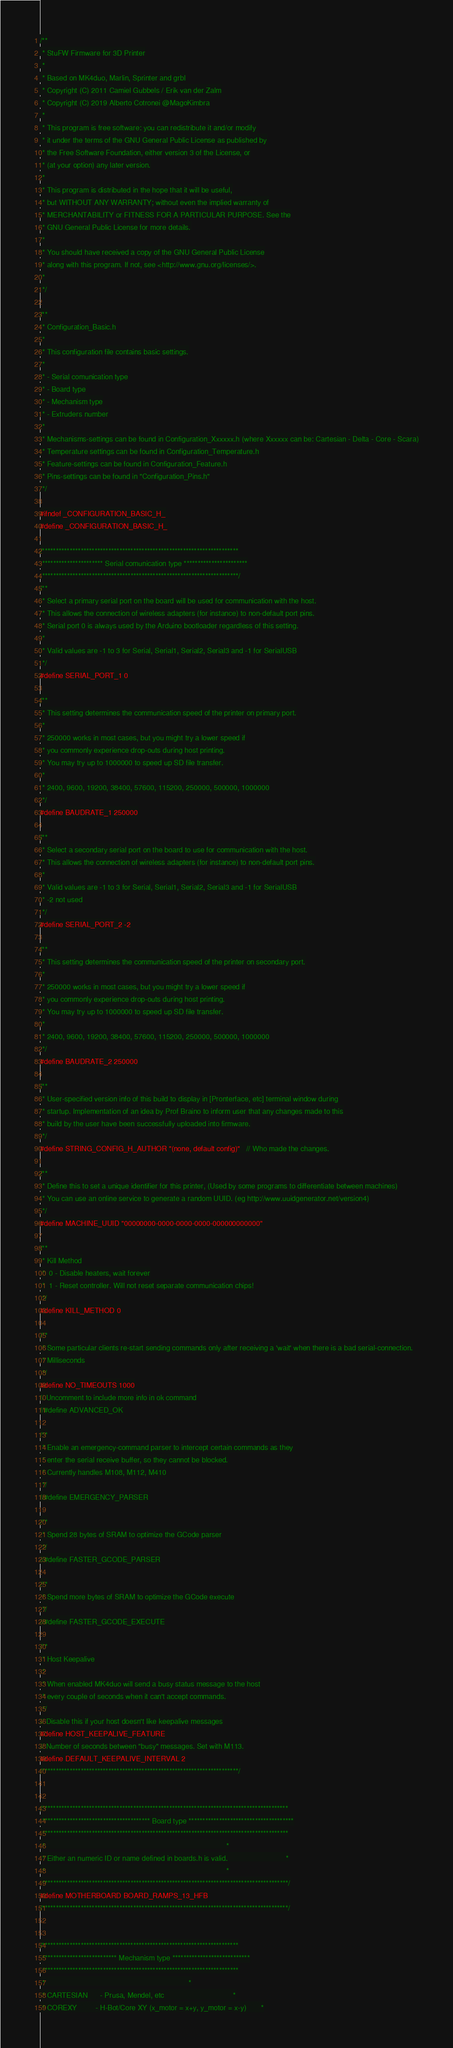<code> <loc_0><loc_0><loc_500><loc_500><_C_>/**
 * StuFW Firmware for 3D Printer
 *
 * Based on MK4duo, Marlin, Sprinter and grbl
 * Copyright (C) 2011 Camiel Gubbels / Erik van der Zalm
 * Copyright (C) 2019 Alberto Cotronei @MagoKimbra
 *
 * This program is free software: you can redistribute it and/or modify
 * it under the terms of the GNU General Public License as published by
 * the Free Software Foundation, either version 3 of the License, or
 * (at your option) any later version.
 *
 * This program is distributed in the hope that it will be useful,
 * but WITHOUT ANY WARRANTY; without even the implied warranty of
 * MERCHANTABILITY or FITNESS FOR A PARTICULAR PURPOSE. See the
 * GNU General Public License for more details.
 *
 * You should have received a copy of the GNU General Public License
 * along with this program. If not, see <http://www.gnu.org/licenses/>.
 *
 */

/**
 * Configuration_Basic.h
 *
 * This configuration file contains basic settings.
 *
 * - Serial comunication type
 * - Board type
 * - Mechanism type
 * - Extruders number
 *
 * Mechanisms-settings can be found in Configuration_Xxxxxx.h (where Xxxxxx can be: Cartesian - Delta - Core - Scara)
 * Temperature settings can be found in Configuration_Temperature.h
 * Feature-settings can be found in Configuration_Feature.h
 * Pins-settings can be found in "Configuration_Pins.h"
 */

#ifndef _CONFIGURATION_BASIC_H_
#define _CONFIGURATION_BASIC_H_

/***********************************************************************
 ********************** Serial comunication type ***********************
 ***********************************************************************/
/**
 * Select a primary serial port on the board will be used for communication with the host.
 * This allows the connection of wireless adapters (for instance) to non-default port pins.
 * Serial port 0 is always used by the Arduino bootloader regardless of this setting.
 *
 * Valid values are -1 to 3 for Serial, Serial1, Serial2, Serial3 and -1 for SerialUSB
 */
#define SERIAL_PORT_1 0

/**
 * This setting determines the communication speed of the printer on primary port.
 *
 * 250000 works in most cases, but you might try a lower speed if
 * you commonly experience drop-outs during host printing.
 * You may try up to 1000000 to speed up SD file transfer.
 *
 * 2400, 9600, 19200, 38400, 57600, 115200, 250000, 500000, 1000000
 */
#define BAUDRATE_1 250000

/**
 * Select a secondary serial port on the board to use for communication with the host.
 * This allows the connection of wireless adapters (for instance) to non-default port pins.
 *
 * Valid values are -1 to 3 for Serial, Serial1, Serial2, Serial3 and -1 for SerialUSB
 * -2 not used
 */
#define SERIAL_PORT_2 -2

/**
 * This setting determines the communication speed of the printer on secondary port.
 *
 * 250000 works in most cases, but you might try a lower speed if
 * you commonly experience drop-outs during host printing.
 * You may try up to 1000000 to speed up SD file transfer.
 *
 * 2400, 9600, 19200, 38400, 57600, 115200, 250000, 500000, 1000000
 */
#define BAUDRATE_2 250000

/**
 * User-specified version info of this build to display in [Pronterface, etc] terminal window during
 * startup. Implementation of an idea by Prof Braino to inform user that any changes made to this
 * build by the user have been successfully uploaded into firmware.
 */
#define STRING_CONFIG_H_AUTHOR "(none, default config)"   // Who made the changes.

/**
 * Define this to set a unique identifier for this printer, (Used by some programs to differentiate between machines)
 * You can use an online service to generate a random UUID. (eg http://www.uuidgenerator.net/version4)
 */
#define MACHINE_UUID "00000000-0000-0000-0000-000000000000"

/**
 * Kill Method
 *  0 - Disable heaters, wait forever
 *  1 - Reset controller. Will not reset separate communication chips!
 */
#define KILL_METHOD 0

/**
 * Some particular clients re-start sending commands only after receiving a 'wait' when there is a bad serial-connection.
 * Milliseconds
 */
#define NO_TIMEOUTS 1000
// Uncomment to include more info in ok command
//#define ADVANCED_OK

/**
 * Enable an emergency-command parser to intercept certain commands as they
 * enter the serial receive buffer, so they cannot be blocked.
 * Currently handles M108, M112, M410
 */
//#define EMERGENCY_PARSER

/**
 * Spend 28 bytes of SRAM to optimize the GCode parser
 */
//#define FASTER_GCODE_PARSER

/**
 * Spend more bytes of SRAM to optimize the GCode execute
 */
//#define FASTER_GCODE_EXECUTE

/**
 * Host Keepalive
 *
 * When enabled MK4duo will send a busy status message to the host
 * every couple of seconds when it can't accept commands.
 */
// Disable this if your host doesn't like keepalive messages
#define HOST_KEEPALIVE_FEATURE
// Number of seconds between "busy" messages. Set with M113.
#define DEFAULT_KEEPALIVE_INTERVAL 2
/***********************************************************************/


/*****************************************************************************************
 *************************************** Board type **************************************
 *****************************************************************************************
 *                                                                                       *
 * Either an numeric ID or name defined in boards.h is valid.                            *
 *                                                                                       *
 *****************************************************************************************/
#define MOTHERBOARD BOARD_RAMPS_13_HFB
/*****************************************************************************************/


/***********************************************************************
 *************************** Mechanism type ****************************
 ***********************************************************************
 *                                                                     *
 * CARTESIAN      - Prusa, Mendel, etc                                 *
 * COREXY         - H-Bot/Core XY (x_motor = x+y, y_motor = x-y)       *</code> 